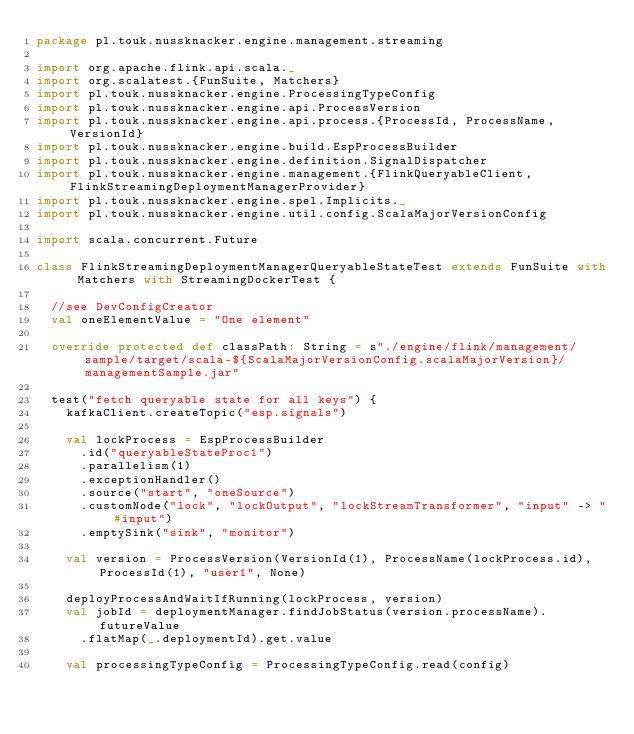<code> <loc_0><loc_0><loc_500><loc_500><_Scala_>package pl.touk.nussknacker.engine.management.streaming

import org.apache.flink.api.scala._
import org.scalatest.{FunSuite, Matchers}
import pl.touk.nussknacker.engine.ProcessingTypeConfig
import pl.touk.nussknacker.engine.api.ProcessVersion
import pl.touk.nussknacker.engine.api.process.{ProcessId, ProcessName, VersionId}
import pl.touk.nussknacker.engine.build.EspProcessBuilder
import pl.touk.nussknacker.engine.definition.SignalDispatcher
import pl.touk.nussknacker.engine.management.{FlinkQueryableClient, FlinkStreamingDeploymentManagerProvider}
import pl.touk.nussknacker.engine.spel.Implicits._
import pl.touk.nussknacker.engine.util.config.ScalaMajorVersionConfig

import scala.concurrent.Future

class FlinkStreamingDeploymentManagerQueryableStateTest extends FunSuite with Matchers with StreamingDockerTest {

  //see DevConfigCreator
  val oneElementValue = "One element"

  override protected def classPath: String = s"./engine/flink/management/sample/target/scala-${ScalaMajorVersionConfig.scalaMajorVersion}/managementSample.jar"

  test("fetch queryable state for all keys") {
    kafkaClient.createTopic("esp.signals")

    val lockProcess = EspProcessBuilder
      .id("queryableStateProc1")
      .parallelism(1)
      .exceptionHandler()
      .source("start", "oneSource")
      .customNode("lock", "lockOutput", "lockStreamTransformer", "input" -> "#input")
      .emptySink("sink", "monitor")

    val version = ProcessVersion(VersionId(1), ProcessName(lockProcess.id), ProcessId(1), "user1", None)

    deployProcessAndWaitIfRunning(lockProcess, version)
    val jobId = deploymentManager.findJobStatus(version.processName).futureValue
      .flatMap(_.deploymentId).get.value

    val processingTypeConfig = ProcessingTypeConfig.read(config)</code> 